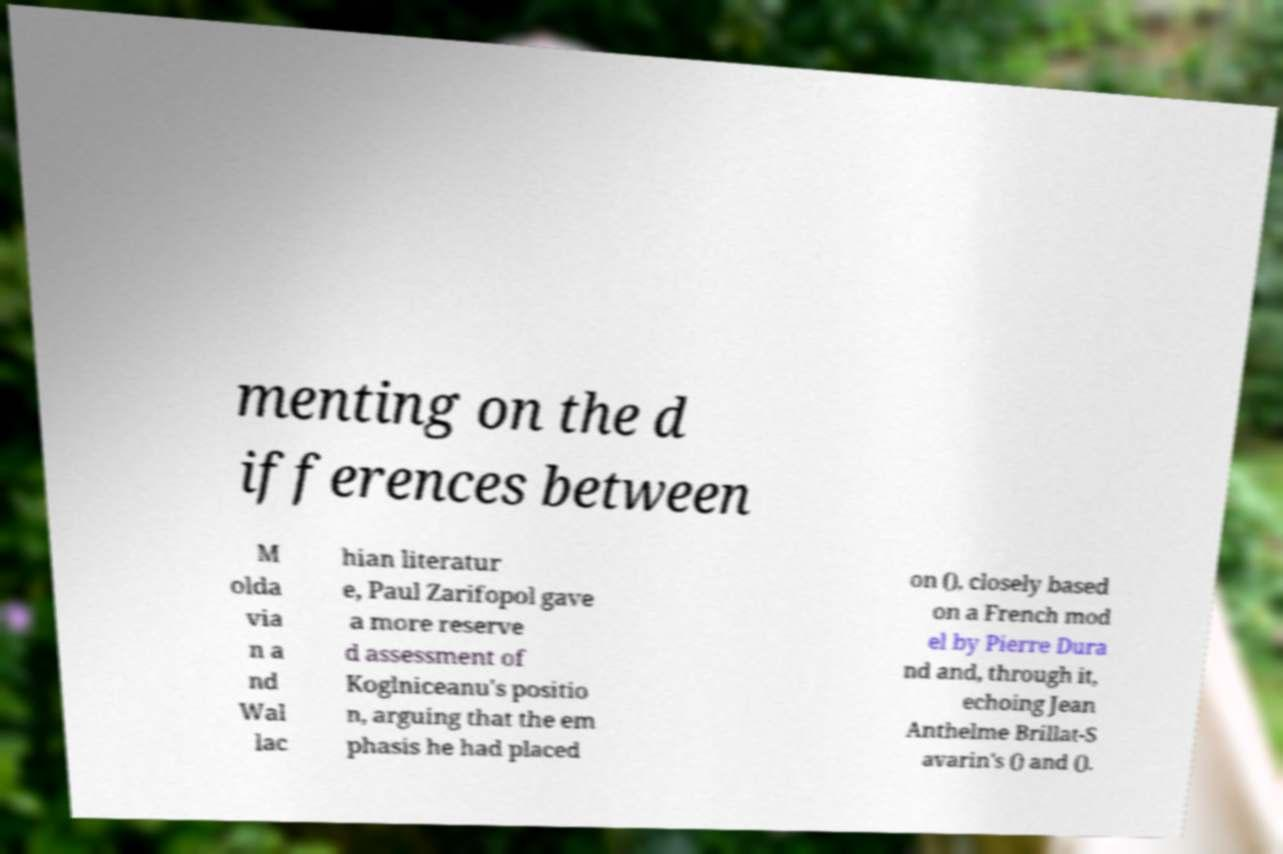Please read and relay the text visible in this image. What does it say? menting on the d ifferences between M olda via n a nd Wal lac hian literatur e, Paul Zarifopol gave a more reserve d assessment of Koglniceanu's positio n, arguing that the em phasis he had placed on (), closely based on a French mod el by Pierre Dura nd and, through it, echoing Jean Anthelme Brillat-S avarin's () and (). 